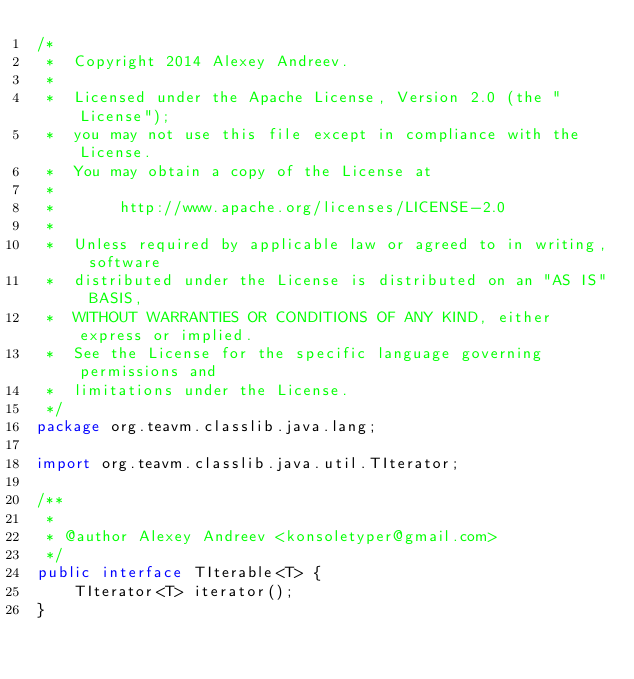Convert code to text. <code><loc_0><loc_0><loc_500><loc_500><_Java_>/*
 *  Copyright 2014 Alexey Andreev.
 *
 *  Licensed under the Apache License, Version 2.0 (the "License");
 *  you may not use this file except in compliance with the License.
 *  You may obtain a copy of the License at
 *
 *       http://www.apache.org/licenses/LICENSE-2.0
 *
 *  Unless required by applicable law or agreed to in writing, software
 *  distributed under the License is distributed on an "AS IS" BASIS,
 *  WITHOUT WARRANTIES OR CONDITIONS OF ANY KIND, either express or implied.
 *  See the License for the specific language governing permissions and
 *  limitations under the License.
 */
package org.teavm.classlib.java.lang;

import org.teavm.classlib.java.util.TIterator;

/**
 *
 * @author Alexey Andreev <konsoletyper@gmail.com>
 */
public interface TIterable<T> {
    TIterator<T> iterator();
}
</code> 